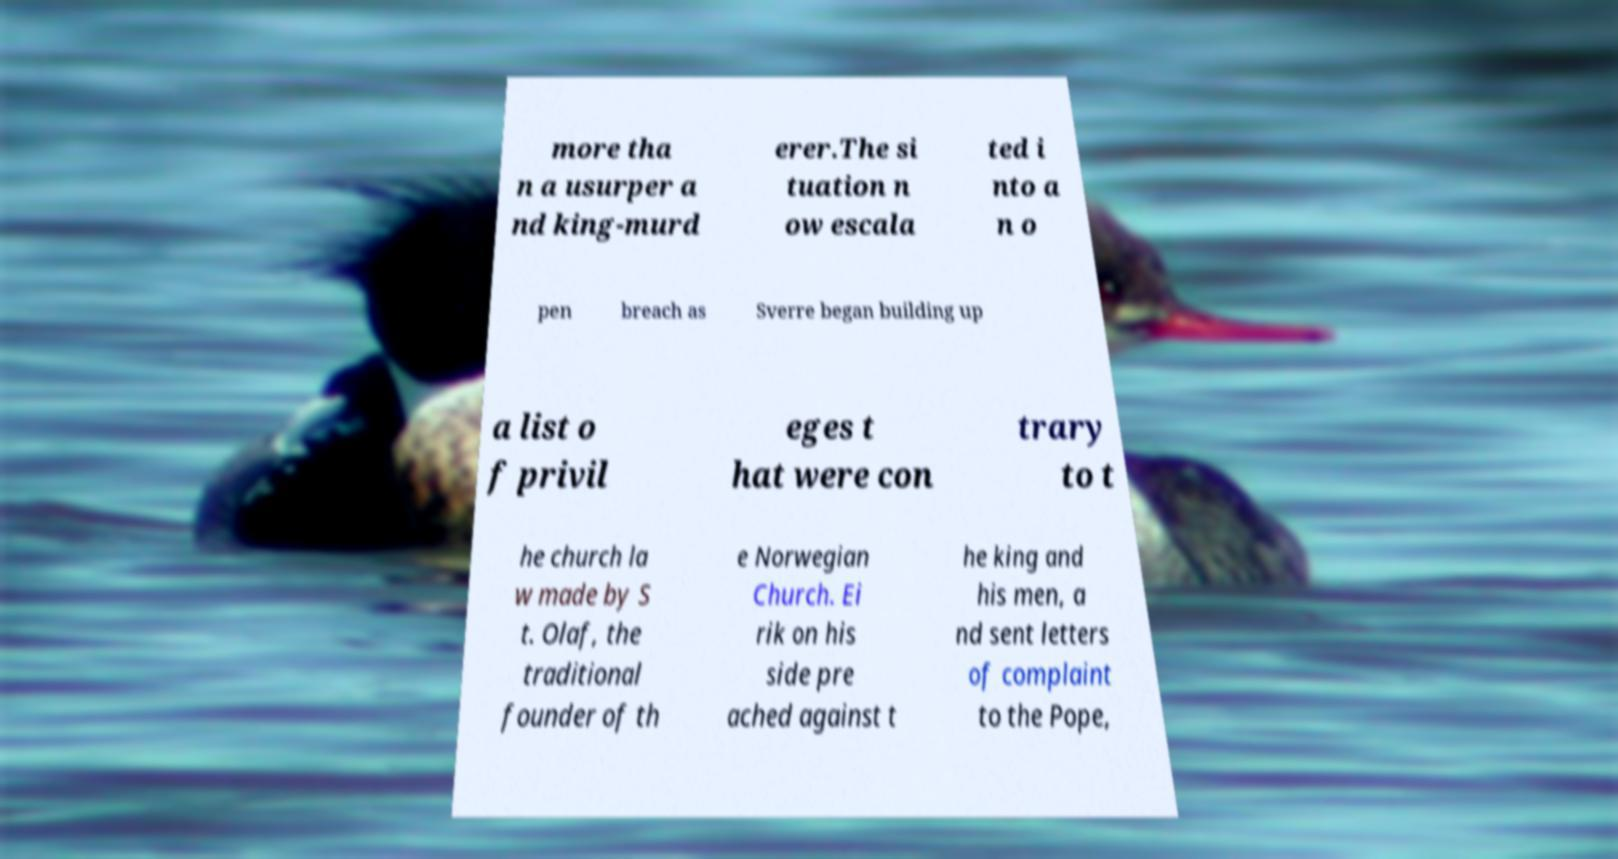I need the written content from this picture converted into text. Can you do that? more tha n a usurper a nd king-murd erer.The si tuation n ow escala ted i nto a n o pen breach as Sverre began building up a list o f privil eges t hat were con trary to t he church la w made by S t. Olaf, the traditional founder of th e Norwegian Church. Ei rik on his side pre ached against t he king and his men, a nd sent letters of complaint to the Pope, 